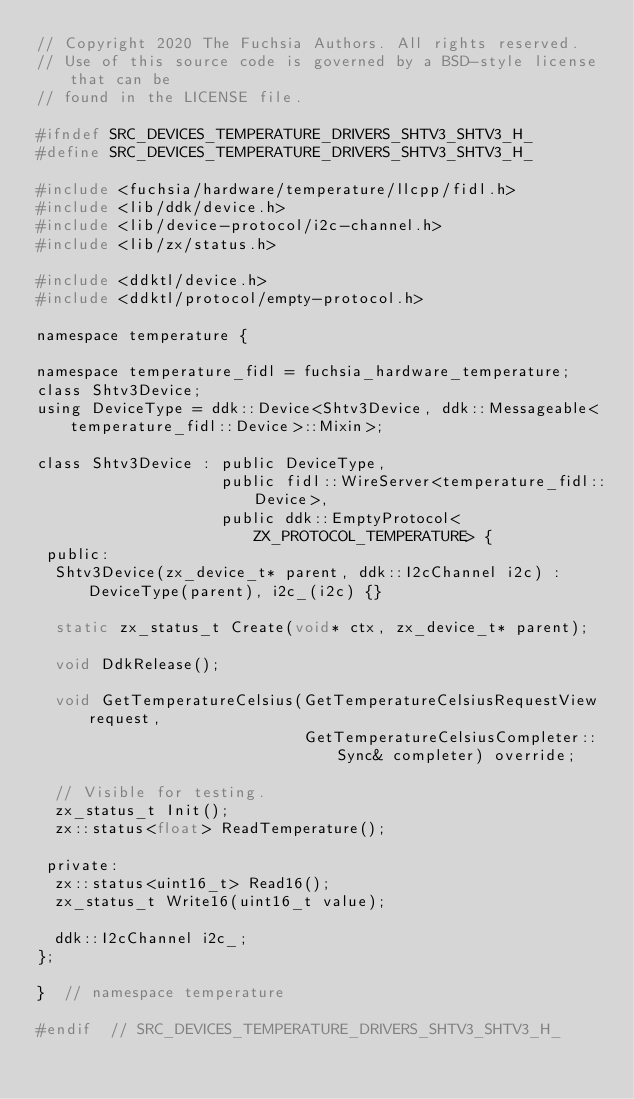<code> <loc_0><loc_0><loc_500><loc_500><_C_>// Copyright 2020 The Fuchsia Authors. All rights reserved.
// Use of this source code is governed by a BSD-style license that can be
// found in the LICENSE file.

#ifndef SRC_DEVICES_TEMPERATURE_DRIVERS_SHTV3_SHTV3_H_
#define SRC_DEVICES_TEMPERATURE_DRIVERS_SHTV3_SHTV3_H_

#include <fuchsia/hardware/temperature/llcpp/fidl.h>
#include <lib/ddk/device.h>
#include <lib/device-protocol/i2c-channel.h>
#include <lib/zx/status.h>

#include <ddktl/device.h>
#include <ddktl/protocol/empty-protocol.h>

namespace temperature {

namespace temperature_fidl = fuchsia_hardware_temperature;
class Shtv3Device;
using DeviceType = ddk::Device<Shtv3Device, ddk::Messageable<temperature_fidl::Device>::Mixin>;

class Shtv3Device : public DeviceType,
                    public fidl::WireServer<temperature_fidl::Device>,
                    public ddk::EmptyProtocol<ZX_PROTOCOL_TEMPERATURE> {
 public:
  Shtv3Device(zx_device_t* parent, ddk::I2cChannel i2c) : DeviceType(parent), i2c_(i2c) {}

  static zx_status_t Create(void* ctx, zx_device_t* parent);

  void DdkRelease();

  void GetTemperatureCelsius(GetTemperatureCelsiusRequestView request,
                             GetTemperatureCelsiusCompleter::Sync& completer) override;

  // Visible for testing.
  zx_status_t Init();
  zx::status<float> ReadTemperature();

 private:
  zx::status<uint16_t> Read16();
  zx_status_t Write16(uint16_t value);

  ddk::I2cChannel i2c_;
};

}  // namespace temperature

#endif  // SRC_DEVICES_TEMPERATURE_DRIVERS_SHTV3_SHTV3_H_
</code> 